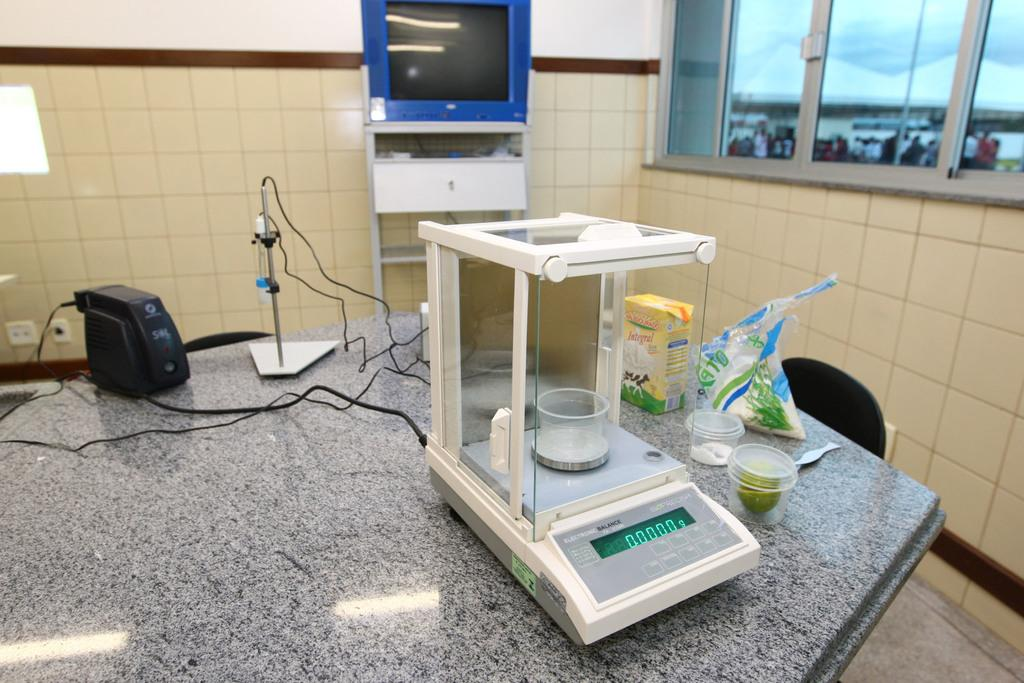<image>
Render a clear and concise summary of the photo. A balance in a lab reads 0.0000 grams and has a small cup on it. 